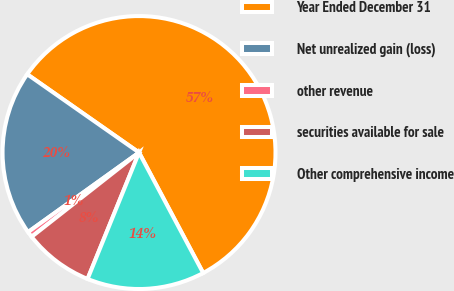Convert chart. <chart><loc_0><loc_0><loc_500><loc_500><pie_chart><fcel>Year Ended December 31<fcel>Net unrealized gain (loss)<fcel>other revenue<fcel>securities available for sale<fcel>Other comprehensive income<nl><fcel>57.5%<fcel>19.62%<fcel>0.69%<fcel>8.26%<fcel>13.94%<nl></chart> 